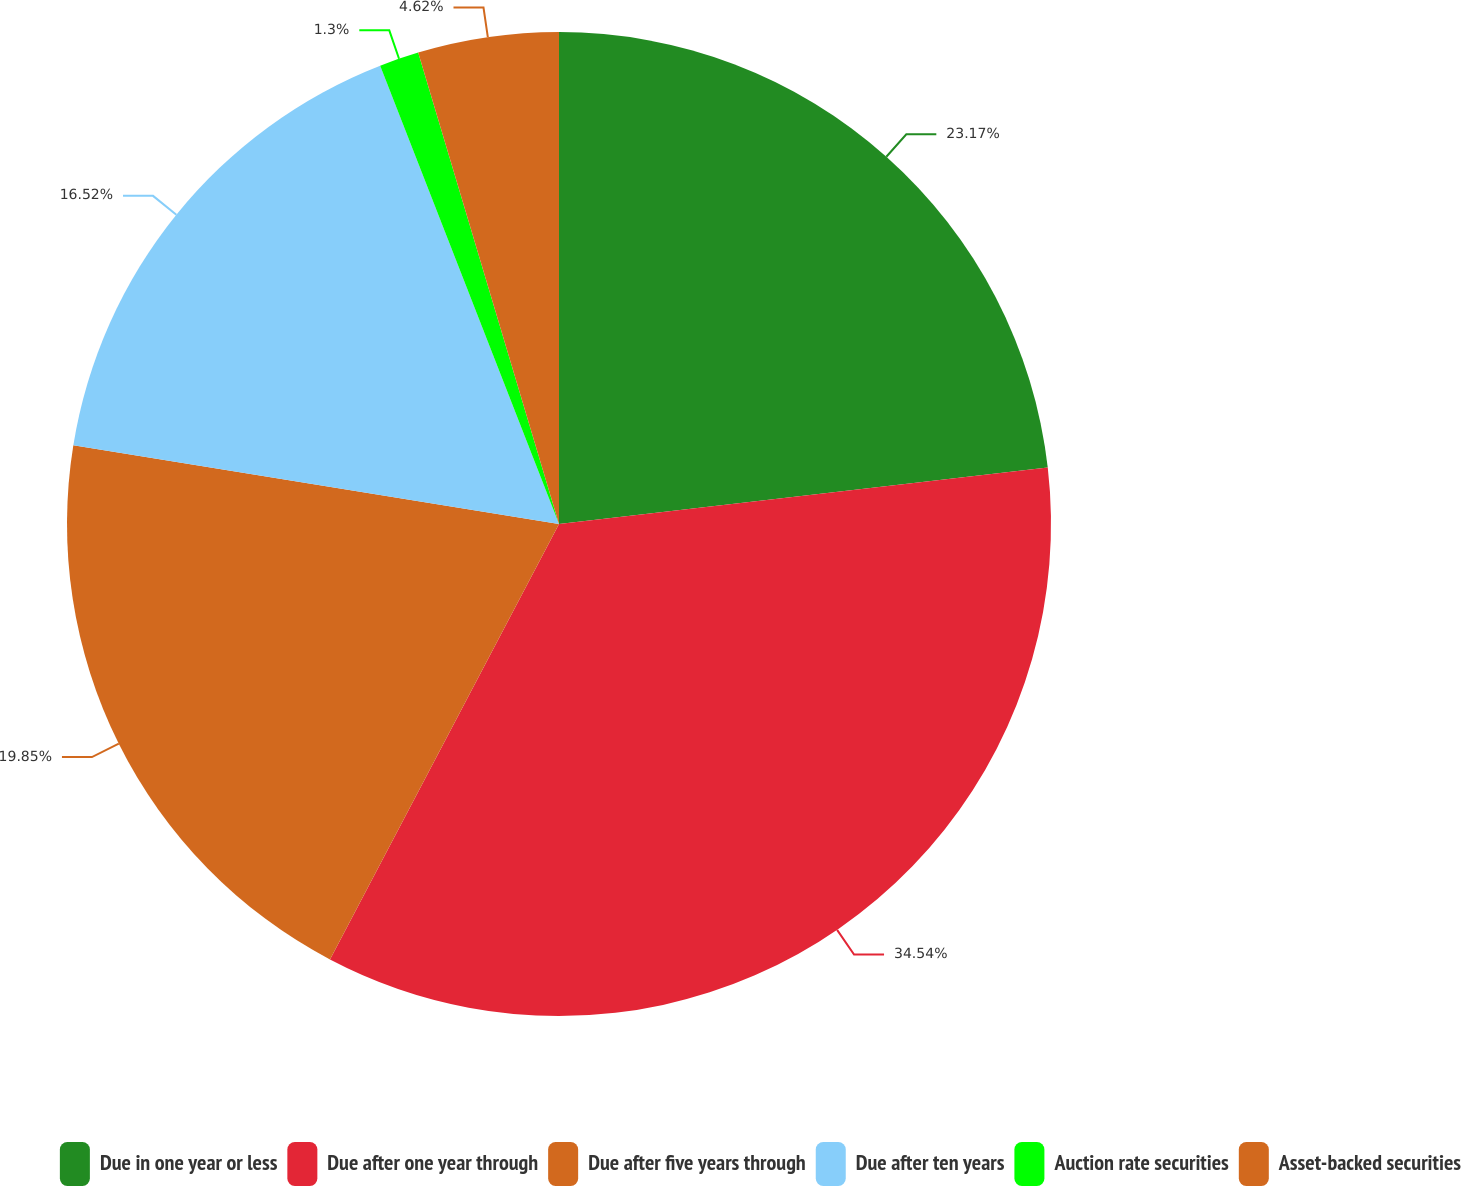Convert chart. <chart><loc_0><loc_0><loc_500><loc_500><pie_chart><fcel>Due in one year or less<fcel>Due after one year through<fcel>Due after five years through<fcel>Due after ten years<fcel>Auction rate securities<fcel>Asset-backed securities<nl><fcel>23.17%<fcel>34.53%<fcel>19.85%<fcel>16.52%<fcel>1.3%<fcel>4.62%<nl></chart> 